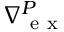<formula> <loc_0><loc_0><loc_500><loc_500>_ { e x } ^ { P }</formula> 